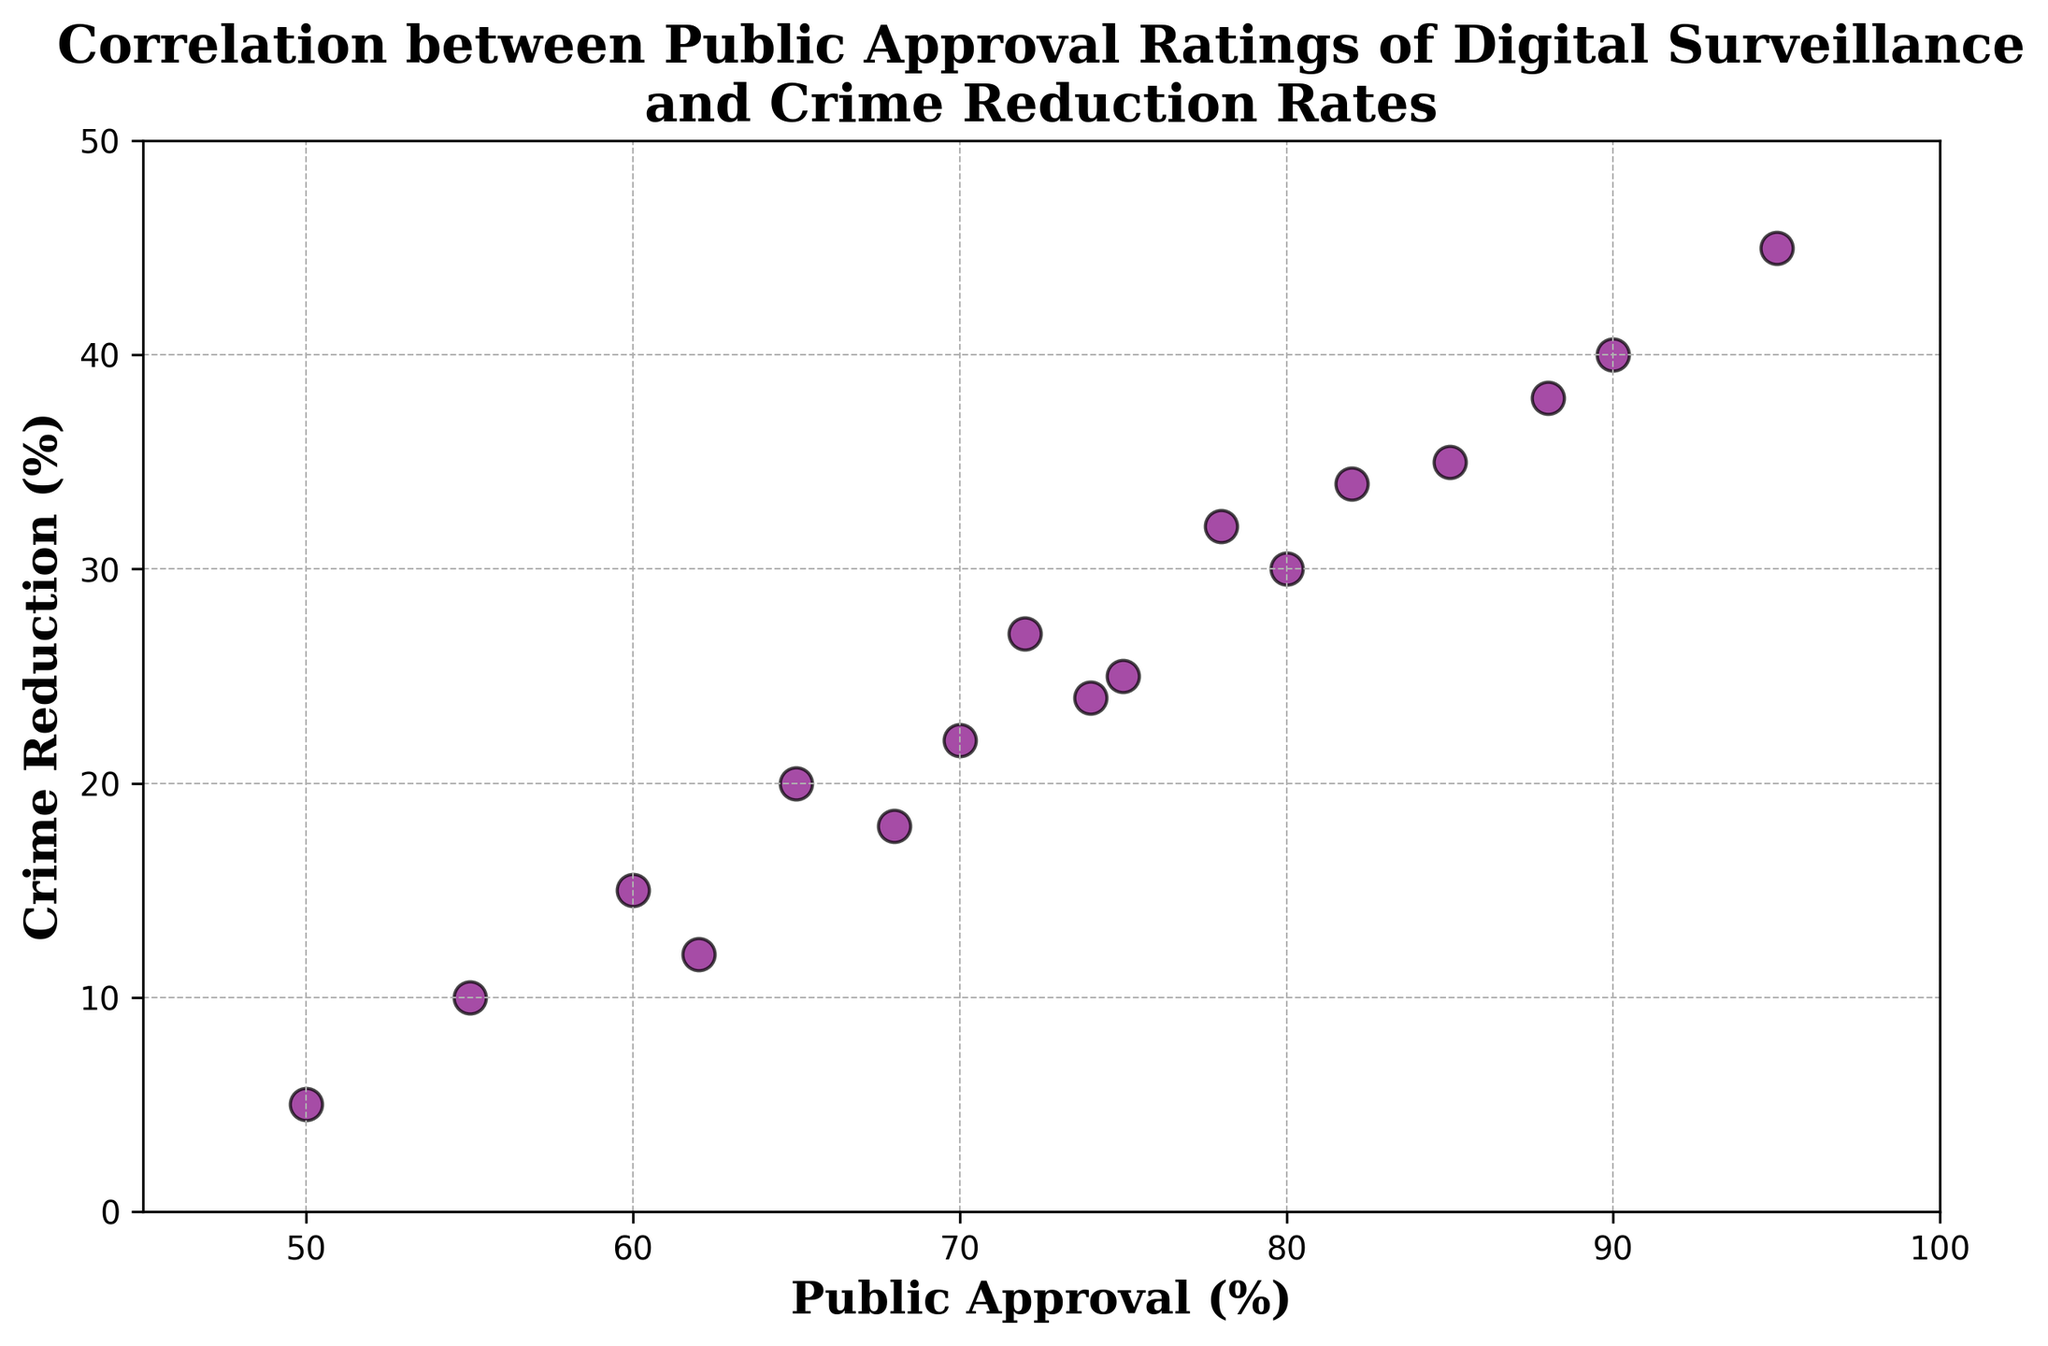What's the average crime reduction rate when public approval is between 70% and 80%? Identify all data points where public approval is between 70% and 80% (inclusive): 70%->22, 72%->27, 74%->24, 75%->25, 78%->32. Sum these values: 22 + 27 + 24 + 25 + 32 = 130. There are 5 data points, so the average is 130 / 5 = 26
Answer: 26 Based on the scatter plot, which approval rating has the lowest crime reduction rate? Observe the y-axis values of crime reduction rates. The data point with the lowest "Crime Reduction" value corresponds to the "Public Approval" value of 50%, with a reduction rate of 5%
Answer: 50% What is the highest crime reduction rate observed, and what is the corresponding public approval rating? Identify the highest point on the y-axis. The highest crime reduction rate is 45%, which corresponds to a public approval rating of 95%
Answer: 45%, 95% At what public approval rating do we first see a crime reduction rate of at least 30%? Locate the points where the crime reduction rate is at least 30%. The first point that meets this criterion is at an approval rating of 80%, with a reduction rate of 30%
Answer: 80% Is there a data point where an approval rating above 80% does not result in a crime reduction rate above 30%? Check the points with an approval rating above 80%. They are: 82%->34, 85%->35, 88%->38, 90%->40, 95%->45. All these points show crime reduction rates above 30%
Answer: No What's the range of crime reduction rates for approval ratings between 60% and 70%? Identify all data points where approval ratings are between 60% and 70% (inclusive): 60%->15, 62%->12, 65%->20, 68%->18, 70%->22. The range is the maximum value minus the minimum value: 22 - 12 = 10
Answer: 10 Which two public approval ratings have the closest crime reduction rates? Compare crime reduction rates across all approval ratings to find the smallest difference. The closest are 70% (22%) and 72% (27%) with a difference of 5
Answer: 70% and 72% What is the median crime reduction rate for the data points shown in the scatter plot? List out all crime reduction rates: 5, 10, 12, 15, 18, 20, 22, 24, 25, 27, 30, 32, 34, 35, 38, 40, 45. Order them: 5, 10, 12, 15, 18, 20, 22, 24, 25, 27, 30, 32, 34, 35, 38, 40, 45. The middle value (9th in the list of 17) is 25
Answer: 25 